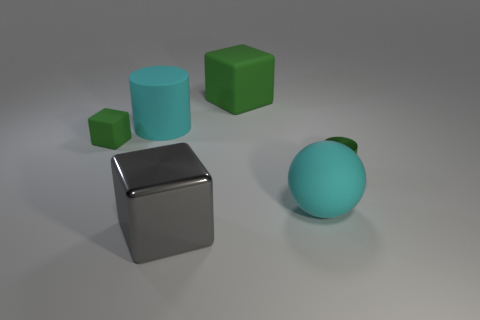Add 4 big green cubes. How many objects exist? 10 Subtract all cylinders. How many objects are left? 4 Subtract 0 gray spheres. How many objects are left? 6 Subtract all cyan matte cylinders. Subtract all tiny green rubber objects. How many objects are left? 4 Add 6 small rubber things. How many small rubber things are left? 7 Add 2 big gray cubes. How many big gray cubes exist? 3 